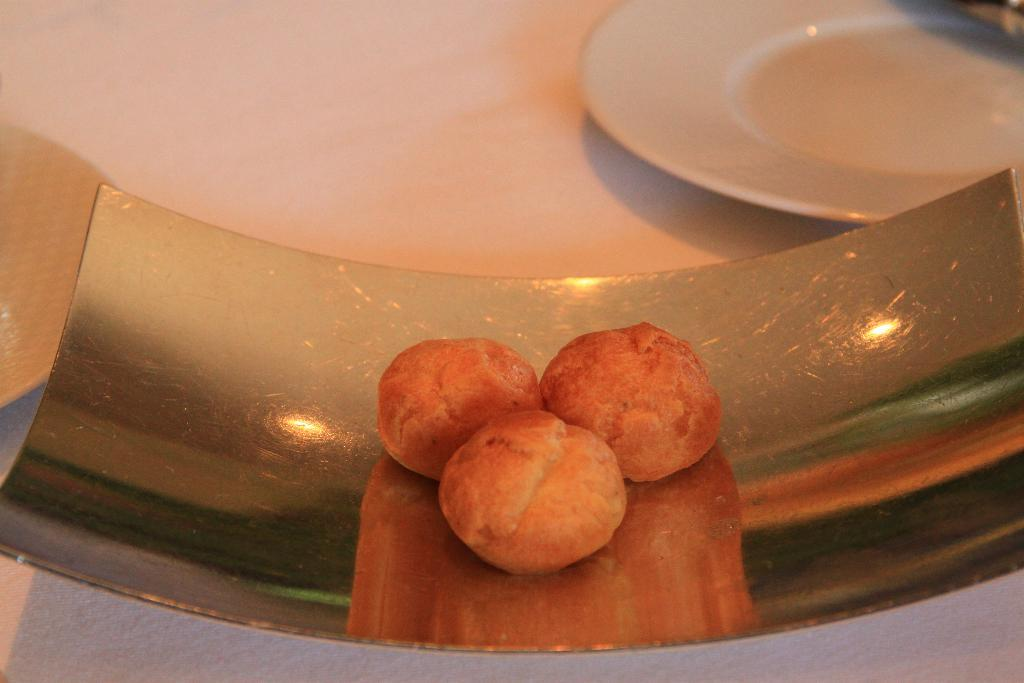What is the main object on the tray in the image? There is a food item on a tray in the image, but no specific details about the food are provided. What other object is near the tray in the image? There is a white plate beside the tray in the image. Is there a lock on the food item to prevent it from being eaten in the image? There is no lock present on the food item in the image. Can you see any quicksand or gates in the image? There is no quicksand or gate present in the image. 